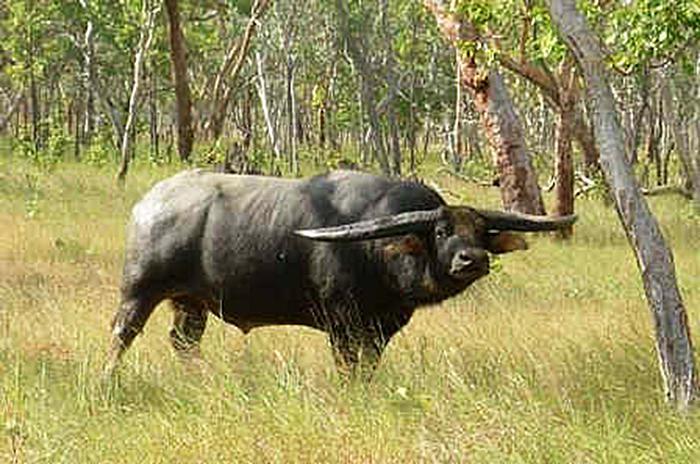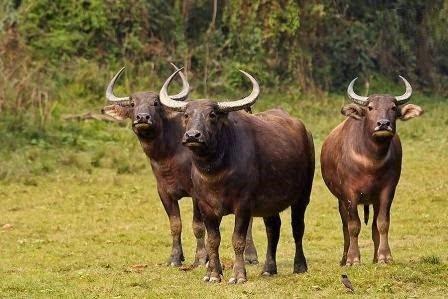The first image is the image on the left, the second image is the image on the right. For the images shown, is this caption "At least two brown animals are facing forward." true? Answer yes or no. Yes. The first image is the image on the left, the second image is the image on the right. Analyze the images presented: Is the assertion "Right image contains at least twice as many horned animals as the left image." valid? Answer yes or no. Yes. 